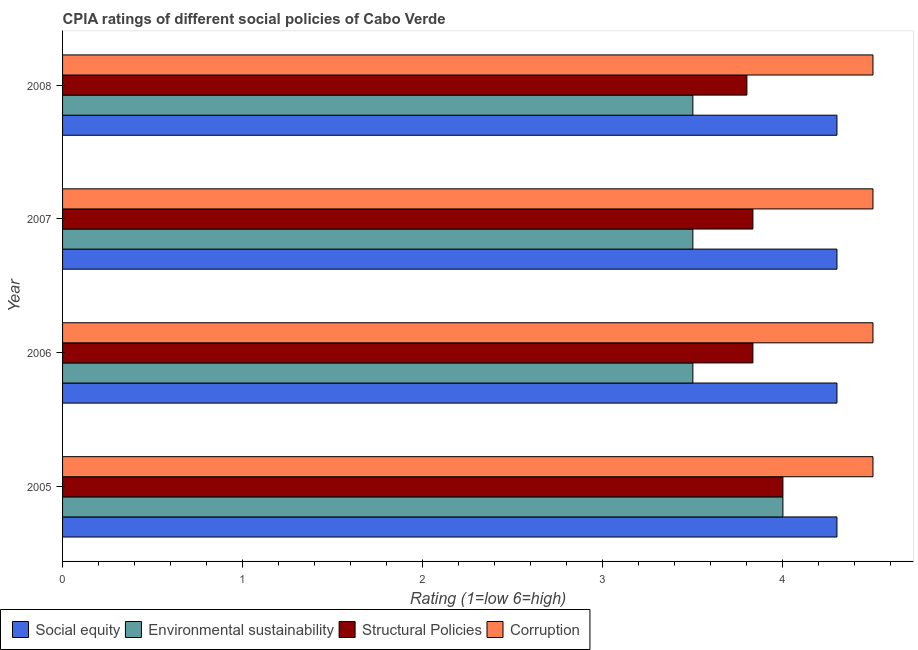How many different coloured bars are there?
Offer a very short reply. 4. How many groups of bars are there?
Provide a succinct answer. 4. Are the number of bars per tick equal to the number of legend labels?
Offer a terse response. Yes. How many bars are there on the 2nd tick from the top?
Provide a short and direct response. 4. What is the difference between the cpia rating of structural policies in 2005 and that in 2006?
Your answer should be very brief. 0.17. What is the average cpia rating of structural policies per year?
Ensure brevity in your answer.  3.87. What is the ratio of the cpia rating of social equity in 2006 to that in 2008?
Keep it short and to the point. 1. Is the cpia rating of social equity in 2005 less than that in 2007?
Offer a terse response. No. What is the difference between the highest and the second highest cpia rating of social equity?
Provide a succinct answer. 0. In how many years, is the cpia rating of environmental sustainability greater than the average cpia rating of environmental sustainability taken over all years?
Provide a short and direct response. 1. Is it the case that in every year, the sum of the cpia rating of corruption and cpia rating of social equity is greater than the sum of cpia rating of environmental sustainability and cpia rating of structural policies?
Ensure brevity in your answer.  Yes. What does the 1st bar from the top in 2008 represents?
Provide a short and direct response. Corruption. What does the 3rd bar from the bottom in 2007 represents?
Keep it short and to the point. Structural Policies. How many years are there in the graph?
Ensure brevity in your answer.  4. Are the values on the major ticks of X-axis written in scientific E-notation?
Offer a terse response. No. Does the graph contain any zero values?
Ensure brevity in your answer.  No. Does the graph contain grids?
Your answer should be compact. No. Where does the legend appear in the graph?
Provide a succinct answer. Bottom left. How are the legend labels stacked?
Give a very brief answer. Horizontal. What is the title of the graph?
Keep it short and to the point. CPIA ratings of different social policies of Cabo Verde. Does "UNDP" appear as one of the legend labels in the graph?
Your answer should be compact. No. What is the label or title of the Y-axis?
Make the answer very short. Year. What is the Rating (1=low 6=high) of Environmental sustainability in 2005?
Provide a short and direct response. 4. What is the Rating (1=low 6=high) in Structural Policies in 2005?
Your answer should be compact. 4. What is the Rating (1=low 6=high) of Corruption in 2005?
Offer a very short reply. 4.5. What is the Rating (1=low 6=high) of Social equity in 2006?
Ensure brevity in your answer.  4.3. What is the Rating (1=low 6=high) of Environmental sustainability in 2006?
Your answer should be very brief. 3.5. What is the Rating (1=low 6=high) in Structural Policies in 2006?
Provide a short and direct response. 3.83. What is the Rating (1=low 6=high) in Corruption in 2006?
Provide a succinct answer. 4.5. What is the Rating (1=low 6=high) in Environmental sustainability in 2007?
Provide a short and direct response. 3.5. What is the Rating (1=low 6=high) of Structural Policies in 2007?
Provide a short and direct response. 3.83. What is the Rating (1=low 6=high) in Corruption in 2007?
Your answer should be very brief. 4.5. What is the Rating (1=low 6=high) of Environmental sustainability in 2008?
Offer a very short reply. 3.5. What is the Rating (1=low 6=high) of Corruption in 2008?
Your answer should be very brief. 4.5. Across all years, what is the maximum Rating (1=low 6=high) in Social equity?
Provide a short and direct response. 4.3. Across all years, what is the minimum Rating (1=low 6=high) in Social equity?
Offer a very short reply. 4.3. Across all years, what is the minimum Rating (1=low 6=high) of Environmental sustainability?
Give a very brief answer. 3.5. Across all years, what is the minimum Rating (1=low 6=high) of Structural Policies?
Your response must be concise. 3.8. What is the total Rating (1=low 6=high) of Social equity in the graph?
Provide a short and direct response. 17.2. What is the total Rating (1=low 6=high) of Environmental sustainability in the graph?
Your answer should be very brief. 14.5. What is the total Rating (1=low 6=high) in Structural Policies in the graph?
Provide a succinct answer. 15.47. What is the difference between the Rating (1=low 6=high) in Social equity in 2005 and that in 2006?
Ensure brevity in your answer.  0. What is the difference between the Rating (1=low 6=high) of Environmental sustainability in 2005 and that in 2006?
Ensure brevity in your answer.  0.5. What is the difference between the Rating (1=low 6=high) of Structural Policies in 2005 and that in 2006?
Provide a succinct answer. 0.17. What is the difference between the Rating (1=low 6=high) in Structural Policies in 2005 and that in 2007?
Offer a very short reply. 0.17. What is the difference between the Rating (1=low 6=high) of Corruption in 2005 and that in 2007?
Give a very brief answer. 0. What is the difference between the Rating (1=low 6=high) of Structural Policies in 2005 and that in 2008?
Keep it short and to the point. 0.2. What is the difference between the Rating (1=low 6=high) in Corruption in 2005 and that in 2008?
Your response must be concise. 0. What is the difference between the Rating (1=low 6=high) in Structural Policies in 2006 and that in 2007?
Offer a very short reply. 0. What is the difference between the Rating (1=low 6=high) of Corruption in 2006 and that in 2007?
Your response must be concise. 0. What is the difference between the Rating (1=low 6=high) of Environmental sustainability in 2006 and that in 2008?
Your response must be concise. 0. What is the difference between the Rating (1=low 6=high) of Structural Policies in 2006 and that in 2008?
Ensure brevity in your answer.  0.03. What is the difference between the Rating (1=low 6=high) in Social equity in 2007 and that in 2008?
Give a very brief answer. 0. What is the difference between the Rating (1=low 6=high) in Environmental sustainability in 2007 and that in 2008?
Offer a very short reply. 0. What is the difference between the Rating (1=low 6=high) of Structural Policies in 2007 and that in 2008?
Provide a succinct answer. 0.03. What is the difference between the Rating (1=low 6=high) of Corruption in 2007 and that in 2008?
Your answer should be very brief. 0. What is the difference between the Rating (1=low 6=high) in Social equity in 2005 and the Rating (1=low 6=high) in Structural Policies in 2006?
Ensure brevity in your answer.  0.47. What is the difference between the Rating (1=low 6=high) in Social equity in 2005 and the Rating (1=low 6=high) in Corruption in 2006?
Make the answer very short. -0.2. What is the difference between the Rating (1=low 6=high) of Environmental sustainability in 2005 and the Rating (1=low 6=high) of Structural Policies in 2006?
Keep it short and to the point. 0.17. What is the difference between the Rating (1=low 6=high) in Social equity in 2005 and the Rating (1=low 6=high) in Environmental sustainability in 2007?
Offer a very short reply. 0.8. What is the difference between the Rating (1=low 6=high) in Social equity in 2005 and the Rating (1=low 6=high) in Structural Policies in 2007?
Ensure brevity in your answer.  0.47. What is the difference between the Rating (1=low 6=high) of Environmental sustainability in 2005 and the Rating (1=low 6=high) of Corruption in 2007?
Ensure brevity in your answer.  -0.5. What is the difference between the Rating (1=low 6=high) in Structural Policies in 2005 and the Rating (1=low 6=high) in Corruption in 2007?
Make the answer very short. -0.5. What is the difference between the Rating (1=low 6=high) in Social equity in 2005 and the Rating (1=low 6=high) in Environmental sustainability in 2008?
Provide a short and direct response. 0.8. What is the difference between the Rating (1=low 6=high) in Social equity in 2005 and the Rating (1=low 6=high) in Corruption in 2008?
Give a very brief answer. -0.2. What is the difference between the Rating (1=low 6=high) in Environmental sustainability in 2005 and the Rating (1=low 6=high) in Structural Policies in 2008?
Your answer should be compact. 0.2. What is the difference between the Rating (1=low 6=high) of Environmental sustainability in 2005 and the Rating (1=low 6=high) of Corruption in 2008?
Make the answer very short. -0.5. What is the difference between the Rating (1=low 6=high) in Social equity in 2006 and the Rating (1=low 6=high) in Structural Policies in 2007?
Your answer should be very brief. 0.47. What is the difference between the Rating (1=low 6=high) in Social equity in 2007 and the Rating (1=low 6=high) in Structural Policies in 2008?
Give a very brief answer. 0.5. What is the average Rating (1=low 6=high) in Social equity per year?
Keep it short and to the point. 4.3. What is the average Rating (1=low 6=high) of Environmental sustainability per year?
Provide a succinct answer. 3.62. What is the average Rating (1=low 6=high) of Structural Policies per year?
Your answer should be very brief. 3.87. In the year 2005, what is the difference between the Rating (1=low 6=high) of Social equity and Rating (1=low 6=high) of Environmental sustainability?
Keep it short and to the point. 0.3. In the year 2005, what is the difference between the Rating (1=low 6=high) in Social equity and Rating (1=low 6=high) in Structural Policies?
Offer a very short reply. 0.3. In the year 2005, what is the difference between the Rating (1=low 6=high) of Social equity and Rating (1=low 6=high) of Corruption?
Your response must be concise. -0.2. In the year 2005, what is the difference between the Rating (1=low 6=high) of Environmental sustainability and Rating (1=low 6=high) of Structural Policies?
Offer a very short reply. 0. In the year 2005, what is the difference between the Rating (1=low 6=high) in Structural Policies and Rating (1=low 6=high) in Corruption?
Provide a short and direct response. -0.5. In the year 2006, what is the difference between the Rating (1=low 6=high) of Social equity and Rating (1=low 6=high) of Environmental sustainability?
Your answer should be compact. 0.8. In the year 2006, what is the difference between the Rating (1=low 6=high) in Social equity and Rating (1=low 6=high) in Structural Policies?
Your answer should be compact. 0.47. In the year 2006, what is the difference between the Rating (1=low 6=high) of Social equity and Rating (1=low 6=high) of Corruption?
Offer a terse response. -0.2. In the year 2006, what is the difference between the Rating (1=low 6=high) in Environmental sustainability and Rating (1=low 6=high) in Structural Policies?
Ensure brevity in your answer.  -0.33. In the year 2006, what is the difference between the Rating (1=low 6=high) of Structural Policies and Rating (1=low 6=high) of Corruption?
Your answer should be very brief. -0.67. In the year 2007, what is the difference between the Rating (1=low 6=high) in Social equity and Rating (1=low 6=high) in Structural Policies?
Ensure brevity in your answer.  0.47. In the year 2008, what is the difference between the Rating (1=low 6=high) of Social equity and Rating (1=low 6=high) of Structural Policies?
Your answer should be compact. 0.5. In the year 2008, what is the difference between the Rating (1=low 6=high) in Social equity and Rating (1=low 6=high) in Corruption?
Offer a very short reply. -0.2. In the year 2008, what is the difference between the Rating (1=low 6=high) in Environmental sustainability and Rating (1=low 6=high) in Structural Policies?
Provide a succinct answer. -0.3. In the year 2008, what is the difference between the Rating (1=low 6=high) in Environmental sustainability and Rating (1=low 6=high) in Corruption?
Offer a very short reply. -1. What is the ratio of the Rating (1=low 6=high) in Environmental sustainability in 2005 to that in 2006?
Ensure brevity in your answer.  1.14. What is the ratio of the Rating (1=low 6=high) in Structural Policies in 2005 to that in 2006?
Offer a terse response. 1.04. What is the ratio of the Rating (1=low 6=high) of Corruption in 2005 to that in 2006?
Your answer should be very brief. 1. What is the ratio of the Rating (1=low 6=high) in Social equity in 2005 to that in 2007?
Offer a terse response. 1. What is the ratio of the Rating (1=low 6=high) in Structural Policies in 2005 to that in 2007?
Your response must be concise. 1.04. What is the ratio of the Rating (1=low 6=high) of Environmental sustainability in 2005 to that in 2008?
Offer a terse response. 1.14. What is the ratio of the Rating (1=low 6=high) in Structural Policies in 2005 to that in 2008?
Give a very brief answer. 1.05. What is the ratio of the Rating (1=low 6=high) in Corruption in 2005 to that in 2008?
Your answer should be compact. 1. What is the ratio of the Rating (1=low 6=high) of Environmental sustainability in 2006 to that in 2007?
Ensure brevity in your answer.  1. What is the ratio of the Rating (1=low 6=high) of Structural Policies in 2006 to that in 2007?
Your response must be concise. 1. What is the ratio of the Rating (1=low 6=high) in Corruption in 2006 to that in 2007?
Provide a succinct answer. 1. What is the ratio of the Rating (1=low 6=high) in Social equity in 2006 to that in 2008?
Your answer should be very brief. 1. What is the ratio of the Rating (1=low 6=high) of Environmental sustainability in 2006 to that in 2008?
Provide a short and direct response. 1. What is the ratio of the Rating (1=low 6=high) in Structural Policies in 2006 to that in 2008?
Your answer should be very brief. 1.01. What is the ratio of the Rating (1=low 6=high) in Social equity in 2007 to that in 2008?
Make the answer very short. 1. What is the ratio of the Rating (1=low 6=high) of Environmental sustainability in 2007 to that in 2008?
Ensure brevity in your answer.  1. What is the ratio of the Rating (1=low 6=high) of Structural Policies in 2007 to that in 2008?
Provide a short and direct response. 1.01. What is the difference between the highest and the second highest Rating (1=low 6=high) in Social equity?
Offer a terse response. 0. What is the difference between the highest and the second highest Rating (1=low 6=high) of Environmental sustainability?
Offer a very short reply. 0.5. What is the difference between the highest and the second highest Rating (1=low 6=high) in Corruption?
Provide a short and direct response. 0. What is the difference between the highest and the lowest Rating (1=low 6=high) in Social equity?
Offer a terse response. 0. What is the difference between the highest and the lowest Rating (1=low 6=high) of Environmental sustainability?
Make the answer very short. 0.5. What is the difference between the highest and the lowest Rating (1=low 6=high) in Corruption?
Give a very brief answer. 0. 